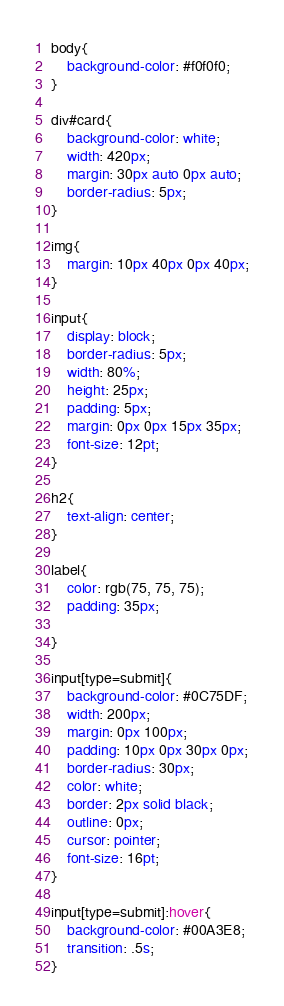Convert code to text. <code><loc_0><loc_0><loc_500><loc_500><_CSS_>body{
	background-color: #f0f0f0;
}

div#card{
	background-color: white;
	width: 420px;
	margin: 30px auto 0px auto;
	border-radius: 5px;
}

img{
	margin: 10px 40px 0px 40px;
}

input{
	display: block;
	border-radius: 5px;
	width: 80%;
	height: 25px;
	padding: 5px;
	margin: 0px 0px 15px 35px;
	font-size: 12pt;
}

h2{
	text-align: center;
}

label{
    color: rgb(75, 75, 75);
    padding: 35px;

}

input[type=submit]{
	background-color: #0C75DF;
	width: 200px;
	margin: 0px 100px;
	padding: 10px 0px 30px 0px;
	border-radius: 30px;
	color: white;
	border: 2px solid black;
	outline: 0px;
	cursor: pointer;
	font-size: 16pt;
}

input[type=submit]:hover{
	background-color: #00A3E8;
	transition: .5s;
}
</code> 